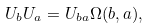<formula> <loc_0><loc_0><loc_500><loc_500>U _ { b } U _ { a } = U _ { b a } \Omega ( b , a ) ,</formula> 